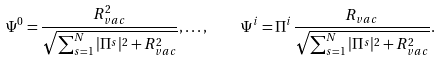Convert formula to latex. <formula><loc_0><loc_0><loc_500><loc_500>\Psi ^ { 0 } = \frac { R _ { v a c } ^ { 2 } } { \sqrt { \sum _ { s = 1 } ^ { N } | \Pi ^ { s } | ^ { 2 } + R _ { v a c } ^ { 2 } } } , \dots , \quad \Psi ^ { i } = \Pi ^ { i } \frac { R _ { v a c } } { \sqrt { \sum _ { s = 1 } ^ { N } | \Pi ^ { s } | ^ { 2 } + R _ { v a c } ^ { 2 } } } .</formula> 